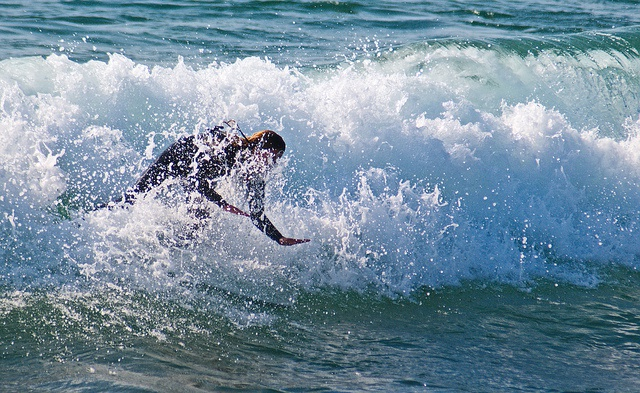Describe the objects in this image and their specific colors. I can see people in teal, lightgray, black, darkgray, and navy tones and surfboard in teal, gray, darkgray, and blue tones in this image. 